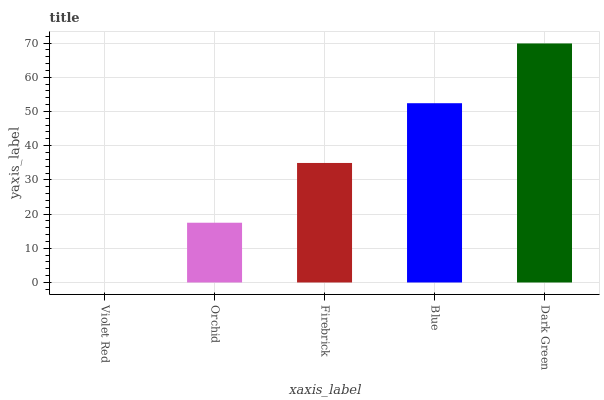Is Violet Red the minimum?
Answer yes or no. Yes. Is Dark Green the maximum?
Answer yes or no. Yes. Is Orchid the minimum?
Answer yes or no. No. Is Orchid the maximum?
Answer yes or no. No. Is Orchid greater than Violet Red?
Answer yes or no. Yes. Is Violet Red less than Orchid?
Answer yes or no. Yes. Is Violet Red greater than Orchid?
Answer yes or no. No. Is Orchid less than Violet Red?
Answer yes or no. No. Is Firebrick the high median?
Answer yes or no. Yes. Is Firebrick the low median?
Answer yes or no. Yes. Is Dark Green the high median?
Answer yes or no. No. Is Orchid the low median?
Answer yes or no. No. 